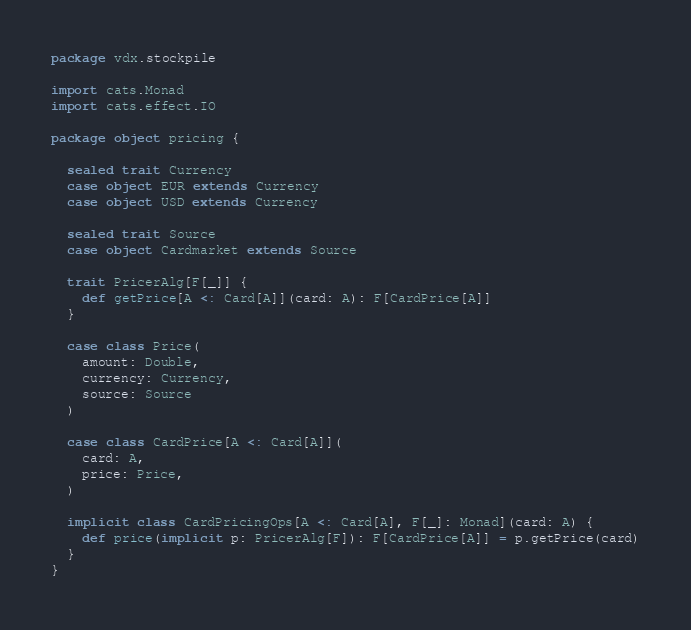<code> <loc_0><loc_0><loc_500><loc_500><_Scala_>package vdx.stockpile

import cats.Monad
import cats.effect.IO

package object pricing {

  sealed trait Currency
  case object EUR extends Currency
  case object USD extends Currency

  sealed trait Source
  case object Cardmarket extends Source

  trait PricerAlg[F[_]] {
    def getPrice[A <: Card[A]](card: A): F[CardPrice[A]]
  }

  case class Price(
    amount: Double,
    currency: Currency,
    source: Source
  )

  case class CardPrice[A <: Card[A]](
    card: A,
    price: Price,
  )

  implicit class CardPricingOps[A <: Card[A], F[_]: Monad](card: A) {
    def price(implicit p: PricerAlg[F]): F[CardPrice[A]] = p.getPrice(card)
  }
}
</code> 